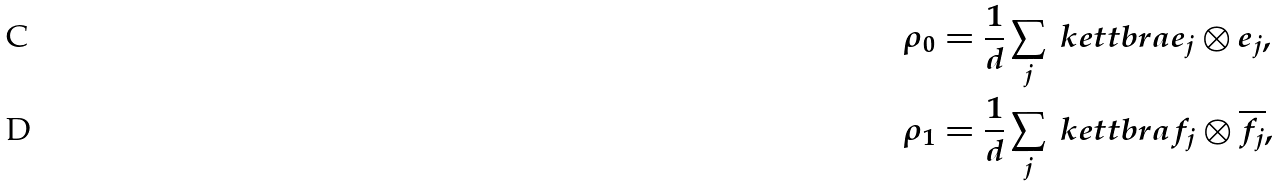Convert formula to latex. <formula><loc_0><loc_0><loc_500><loc_500>\rho _ { 0 } & = \frac { 1 } { d } \sum _ { j } \ k e t t b r a { e _ { j } \otimes e _ { j } } , \\ \rho _ { 1 } & = \frac { 1 } { d } \sum _ { j } \ k e t t b r a { f _ { j } \otimes \overline { f _ { j } } } ,</formula> 